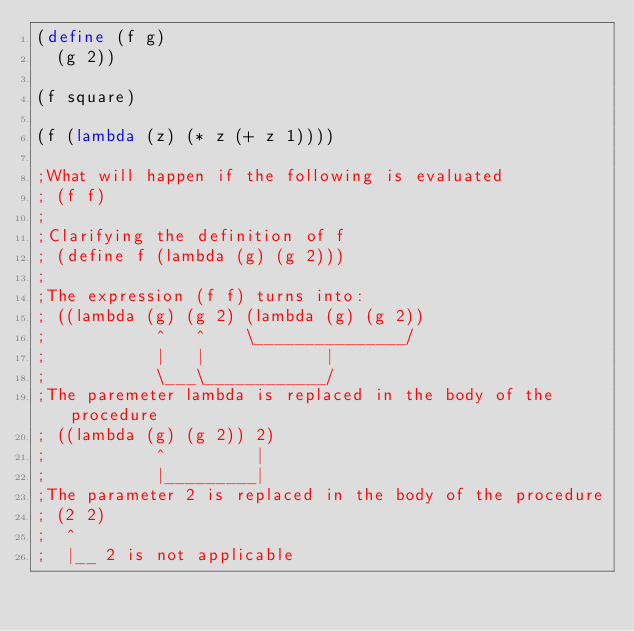<code> <loc_0><loc_0><loc_500><loc_500><_Scheme_>(define (f g)
  (g 2))

(f square)

(f (lambda (z) (* z (+ z 1))))

;What will happen if the following is evaluated
; (f f)
;
;Clarifying the definition of f
; (define f (lambda (g) (g 2)))
;
;The expression (f f) turns into:
; ((lambda (g) (g 2) (lambda (g) (g 2))
;           ^   ^    \_______________/
;           |   |            |
;           \___\____________/
;The paremeter lambda is replaced in the body of the procedure
; ((lambda (g) (g 2)) 2)
;           ^         |
;           |_________|
;The parameter 2 is replaced in the body of the procedure
; (2 2)
;  ^
;  |__ 2 is not applicable


</code> 